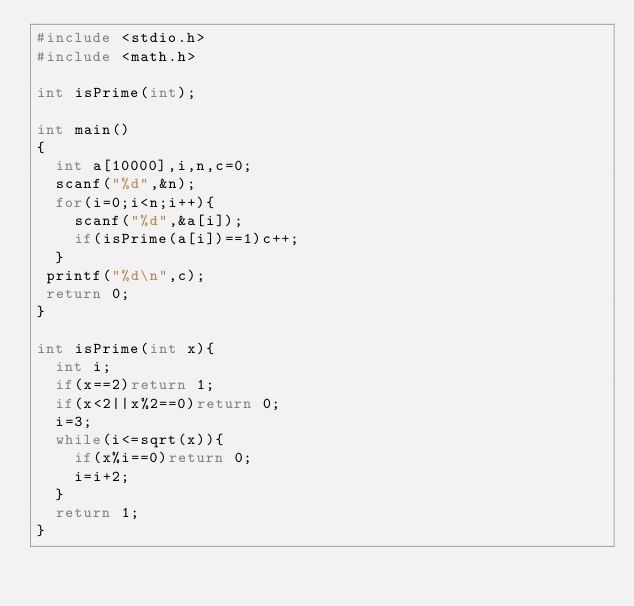Convert code to text. <code><loc_0><loc_0><loc_500><loc_500><_C_>#include <stdio.h>
#include <math.h>
 
int isPrime(int);
 
int main()
{
  int a[10000],i,n,c=0;
  scanf("%d",&n);
  for(i=0;i<n;i++){
    scanf("%d",&a[i]);
    if(isPrime(a[i])==1)c++;
  }
 printf("%d\n",c);
 return 0;
}
     
int isPrime(int x){
  int i;
  if(x==2)return 1;
  if(x<2||x%2==0)return 0;
  i=3;
  while(i<=sqrt(x)){
    if(x%i==0)return 0;
    i=i+2;
  }
  return 1;
}
</code> 